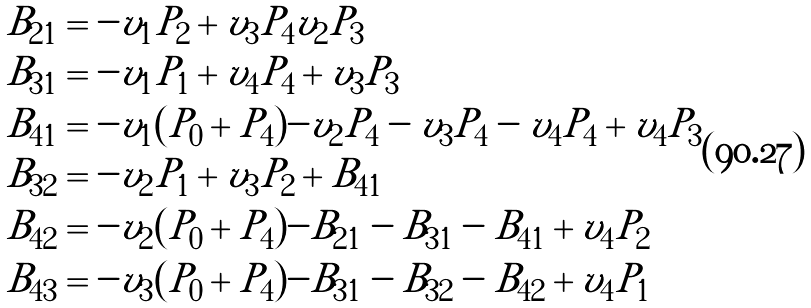<formula> <loc_0><loc_0><loc_500><loc_500>B _ { 2 1 } & = - v _ { 1 } P _ { 2 } + v _ { 3 } P _ { 4 } v _ { 2 } P _ { 3 } \\ B _ { 3 1 } & = - v _ { 1 } P _ { 1 } + v _ { 4 } P _ { 4 } + v _ { 3 } P _ { 3 } \\ B _ { 4 1 } & = - v _ { 1 } ( P _ { 0 } + P _ { 4 } ) - v _ { 2 } P _ { 4 } - v _ { 3 } P _ { 4 } - v _ { 4 } P _ { 4 } + v _ { 4 } P _ { 3 } \\ B _ { 3 2 } & = - v _ { 2 } P _ { 1 } + v _ { 3 } P _ { 2 } + B _ { 4 1 } \\ B _ { 4 2 } & = - v _ { 2 } ( P _ { 0 } + P _ { 4 } ) - B _ { 2 1 } - B _ { 3 1 } - B _ { 4 1 } + v _ { 4 } P _ { 2 } \\ B _ { 4 3 } & = - v _ { 3 } ( P _ { 0 } + P _ { 4 } ) - B _ { 3 1 } - B _ { 3 2 } - B _ { 4 2 } + v _ { 4 } P _ { 1 }</formula> 